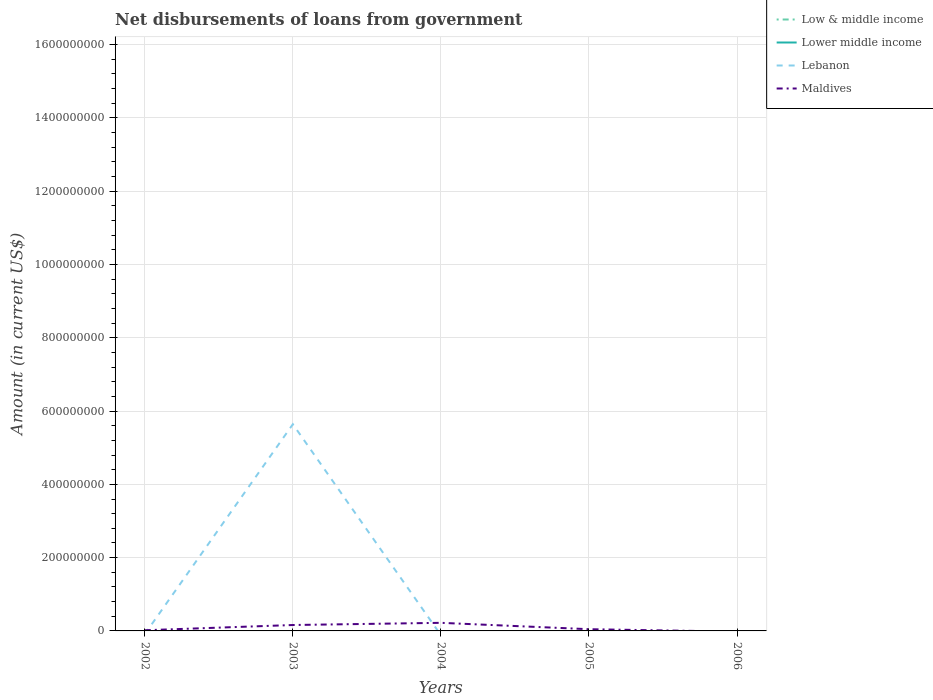How many different coloured lines are there?
Your response must be concise. 2. Is the number of lines equal to the number of legend labels?
Provide a short and direct response. No. What is the total amount of loan disbursed from government in Maldives in the graph?
Your response must be concise. -5.96e+06. What is the difference between the highest and the second highest amount of loan disbursed from government in Maldives?
Your answer should be very brief. 2.21e+07. What is the difference between two consecutive major ticks on the Y-axis?
Give a very brief answer. 2.00e+08. Are the values on the major ticks of Y-axis written in scientific E-notation?
Your answer should be very brief. No. Does the graph contain any zero values?
Ensure brevity in your answer.  Yes. Does the graph contain grids?
Your answer should be very brief. Yes. Where does the legend appear in the graph?
Your response must be concise. Top right. How many legend labels are there?
Provide a succinct answer. 4. What is the title of the graph?
Make the answer very short. Net disbursements of loans from government. Does "Mauritania" appear as one of the legend labels in the graph?
Your response must be concise. No. What is the label or title of the X-axis?
Your answer should be very brief. Years. What is the Amount (in current US$) in Lebanon in 2002?
Your answer should be compact. 0. What is the Amount (in current US$) in Maldives in 2002?
Make the answer very short. 1.83e+06. What is the Amount (in current US$) in Low & middle income in 2003?
Give a very brief answer. 0. What is the Amount (in current US$) of Lebanon in 2003?
Keep it short and to the point. 5.64e+08. What is the Amount (in current US$) in Maldives in 2003?
Make the answer very short. 1.61e+07. What is the Amount (in current US$) in Lebanon in 2004?
Provide a succinct answer. 0. What is the Amount (in current US$) of Maldives in 2004?
Provide a short and direct response. 2.21e+07. What is the Amount (in current US$) of Low & middle income in 2005?
Your answer should be very brief. 0. What is the Amount (in current US$) in Lebanon in 2005?
Keep it short and to the point. 0. What is the Amount (in current US$) of Maldives in 2005?
Keep it short and to the point. 4.68e+06. What is the Amount (in current US$) of Lower middle income in 2006?
Give a very brief answer. 0. What is the Amount (in current US$) in Lebanon in 2006?
Provide a short and direct response. 0. Across all years, what is the maximum Amount (in current US$) in Lebanon?
Ensure brevity in your answer.  5.64e+08. Across all years, what is the maximum Amount (in current US$) of Maldives?
Offer a terse response. 2.21e+07. What is the total Amount (in current US$) in Lebanon in the graph?
Offer a very short reply. 5.64e+08. What is the total Amount (in current US$) of Maldives in the graph?
Offer a terse response. 4.47e+07. What is the difference between the Amount (in current US$) of Maldives in 2002 and that in 2003?
Your answer should be compact. -1.43e+07. What is the difference between the Amount (in current US$) of Maldives in 2002 and that in 2004?
Ensure brevity in your answer.  -2.03e+07. What is the difference between the Amount (in current US$) in Maldives in 2002 and that in 2005?
Offer a terse response. -2.86e+06. What is the difference between the Amount (in current US$) of Maldives in 2003 and that in 2004?
Provide a succinct answer. -5.96e+06. What is the difference between the Amount (in current US$) in Maldives in 2003 and that in 2005?
Provide a succinct answer. 1.14e+07. What is the difference between the Amount (in current US$) of Maldives in 2004 and that in 2005?
Make the answer very short. 1.74e+07. What is the difference between the Amount (in current US$) in Lebanon in 2003 and the Amount (in current US$) in Maldives in 2004?
Make the answer very short. 5.42e+08. What is the difference between the Amount (in current US$) of Lebanon in 2003 and the Amount (in current US$) of Maldives in 2005?
Provide a succinct answer. 5.59e+08. What is the average Amount (in current US$) of Lower middle income per year?
Keep it short and to the point. 0. What is the average Amount (in current US$) in Lebanon per year?
Provide a succinct answer. 1.13e+08. What is the average Amount (in current US$) of Maldives per year?
Your response must be concise. 8.94e+06. In the year 2003, what is the difference between the Amount (in current US$) in Lebanon and Amount (in current US$) in Maldives?
Provide a succinct answer. 5.48e+08. What is the ratio of the Amount (in current US$) in Maldives in 2002 to that in 2003?
Give a very brief answer. 0.11. What is the ratio of the Amount (in current US$) in Maldives in 2002 to that in 2004?
Make the answer very short. 0.08. What is the ratio of the Amount (in current US$) of Maldives in 2002 to that in 2005?
Your answer should be very brief. 0.39. What is the ratio of the Amount (in current US$) in Maldives in 2003 to that in 2004?
Provide a succinct answer. 0.73. What is the ratio of the Amount (in current US$) of Maldives in 2003 to that in 2005?
Give a very brief answer. 3.44. What is the ratio of the Amount (in current US$) of Maldives in 2004 to that in 2005?
Provide a succinct answer. 4.71. What is the difference between the highest and the second highest Amount (in current US$) of Maldives?
Your response must be concise. 5.96e+06. What is the difference between the highest and the lowest Amount (in current US$) in Lebanon?
Ensure brevity in your answer.  5.64e+08. What is the difference between the highest and the lowest Amount (in current US$) of Maldives?
Ensure brevity in your answer.  2.21e+07. 